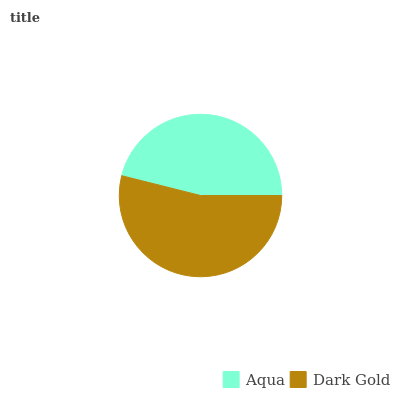Is Aqua the minimum?
Answer yes or no. Yes. Is Dark Gold the maximum?
Answer yes or no. Yes. Is Dark Gold the minimum?
Answer yes or no. No. Is Dark Gold greater than Aqua?
Answer yes or no. Yes. Is Aqua less than Dark Gold?
Answer yes or no. Yes. Is Aqua greater than Dark Gold?
Answer yes or no. No. Is Dark Gold less than Aqua?
Answer yes or no. No. Is Dark Gold the high median?
Answer yes or no. Yes. Is Aqua the low median?
Answer yes or no. Yes. Is Aqua the high median?
Answer yes or no. No. Is Dark Gold the low median?
Answer yes or no. No. 